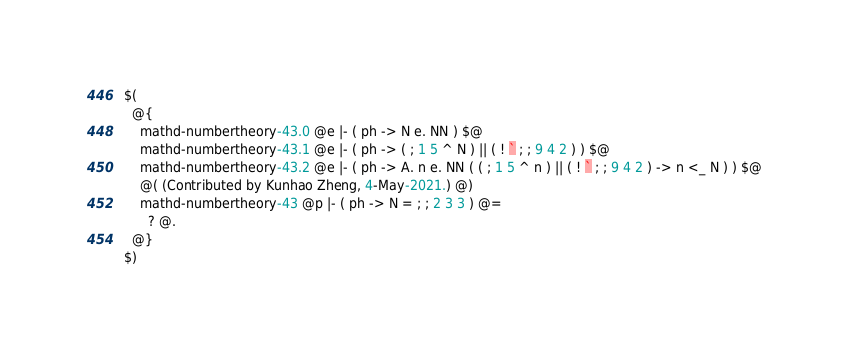<code> <loc_0><loc_0><loc_500><loc_500><_ObjectiveC_>$(
  @{
    mathd-numbertheory-43.0 @e |- ( ph -> N e. NN ) $@
    mathd-numbertheory-43.1 @e |- ( ph -> ( ; 1 5 ^ N ) || ( ! ` ; ; 9 4 2 ) ) $@
    mathd-numbertheory-43.2 @e |- ( ph -> A. n e. NN ( ( ; 1 5 ^ n ) || ( ! ` ; ; 9 4 2 ) -> n <_ N ) ) $@
    @( (Contributed by Kunhao Zheng, 4-May-2021.) @)
    mathd-numbertheory-43 @p |- ( ph -> N = ; ; 2 3 3 ) @=
      ? @.
  @}
$)
</code> 